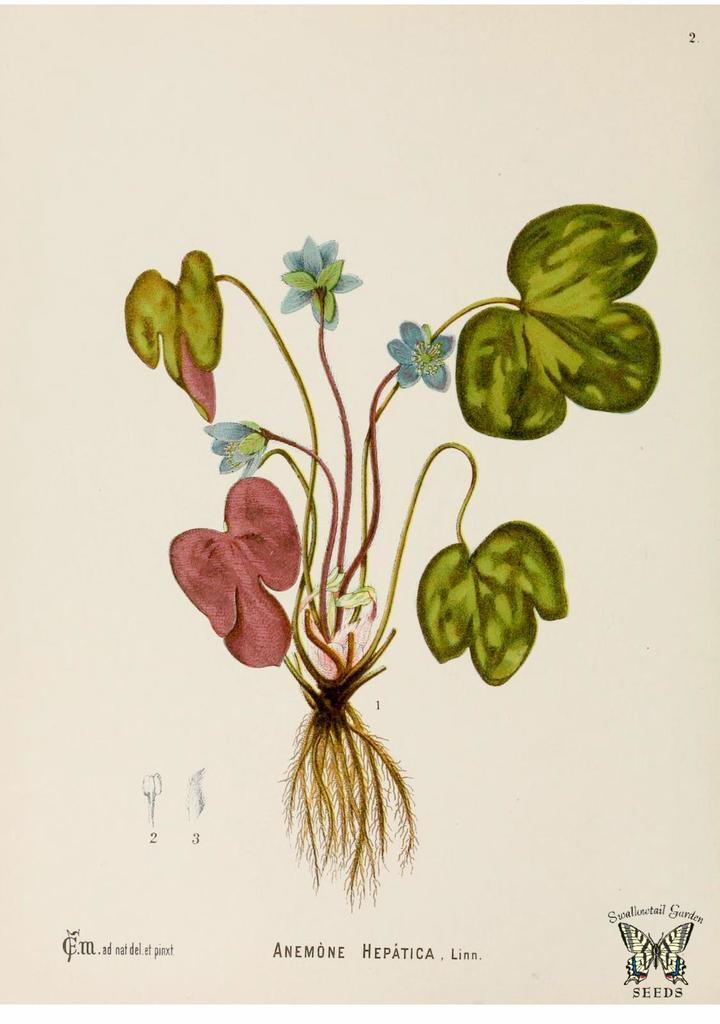Describe this image in one or two sentences. In this image I can see a painting. At the bottom I can see some text. The background is white in color. 